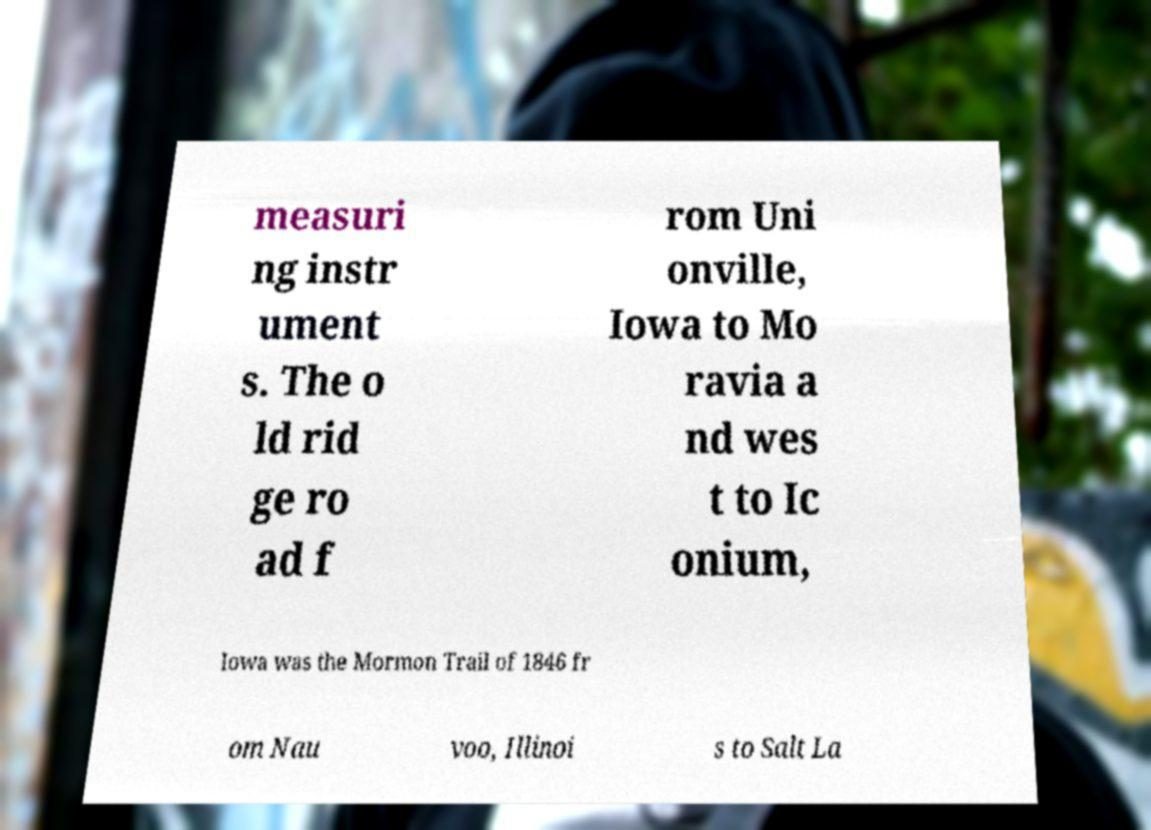There's text embedded in this image that I need extracted. Can you transcribe it verbatim? measuri ng instr ument s. The o ld rid ge ro ad f rom Uni onville, Iowa to Mo ravia a nd wes t to Ic onium, Iowa was the Mormon Trail of 1846 fr om Nau voo, Illinoi s to Salt La 